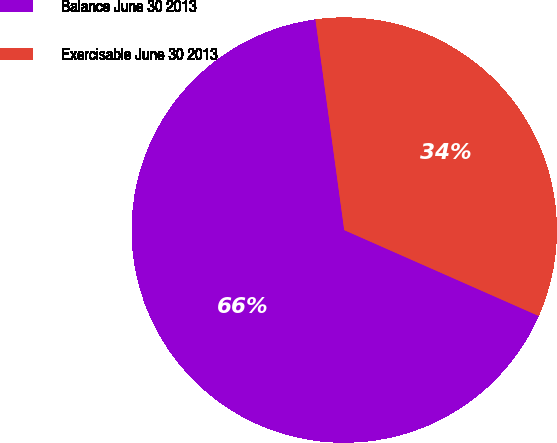Convert chart to OTSL. <chart><loc_0><loc_0><loc_500><loc_500><pie_chart><fcel>Balance June 30 2013<fcel>Exercisable June 30 2013<nl><fcel>66.22%<fcel>33.78%<nl></chart> 